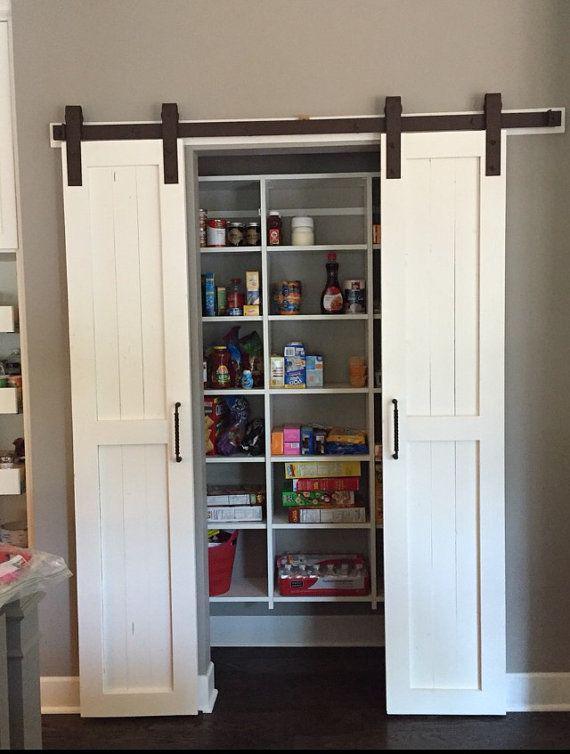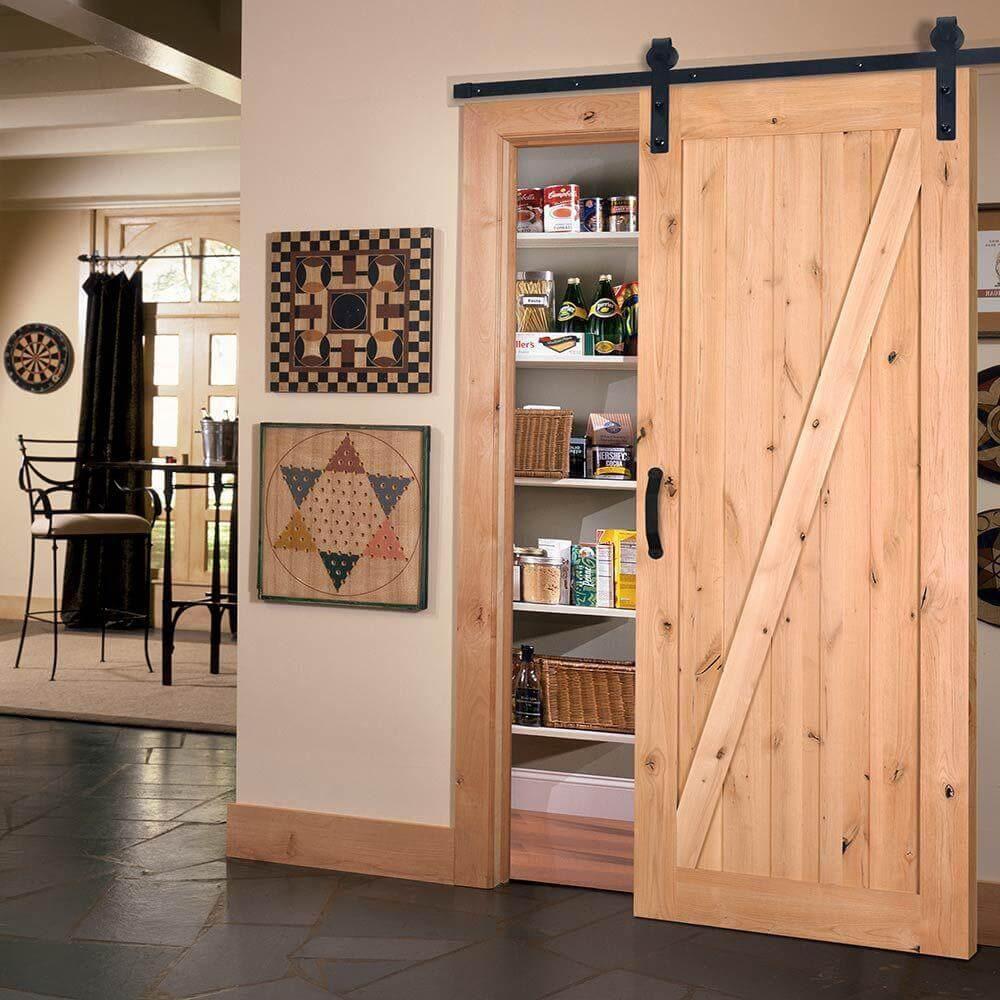The first image is the image on the left, the second image is the image on the right. Given the left and right images, does the statement "The left and right image contains the same number of hanging doors." hold true? Answer yes or no. No. The first image is the image on the left, the second image is the image on the right. Analyze the images presented: Is the assertion "One image shows white barn-style double doors that slide on an overhead black bar, and the doors are open revealing filled shelves." valid? Answer yes or no. Yes. 